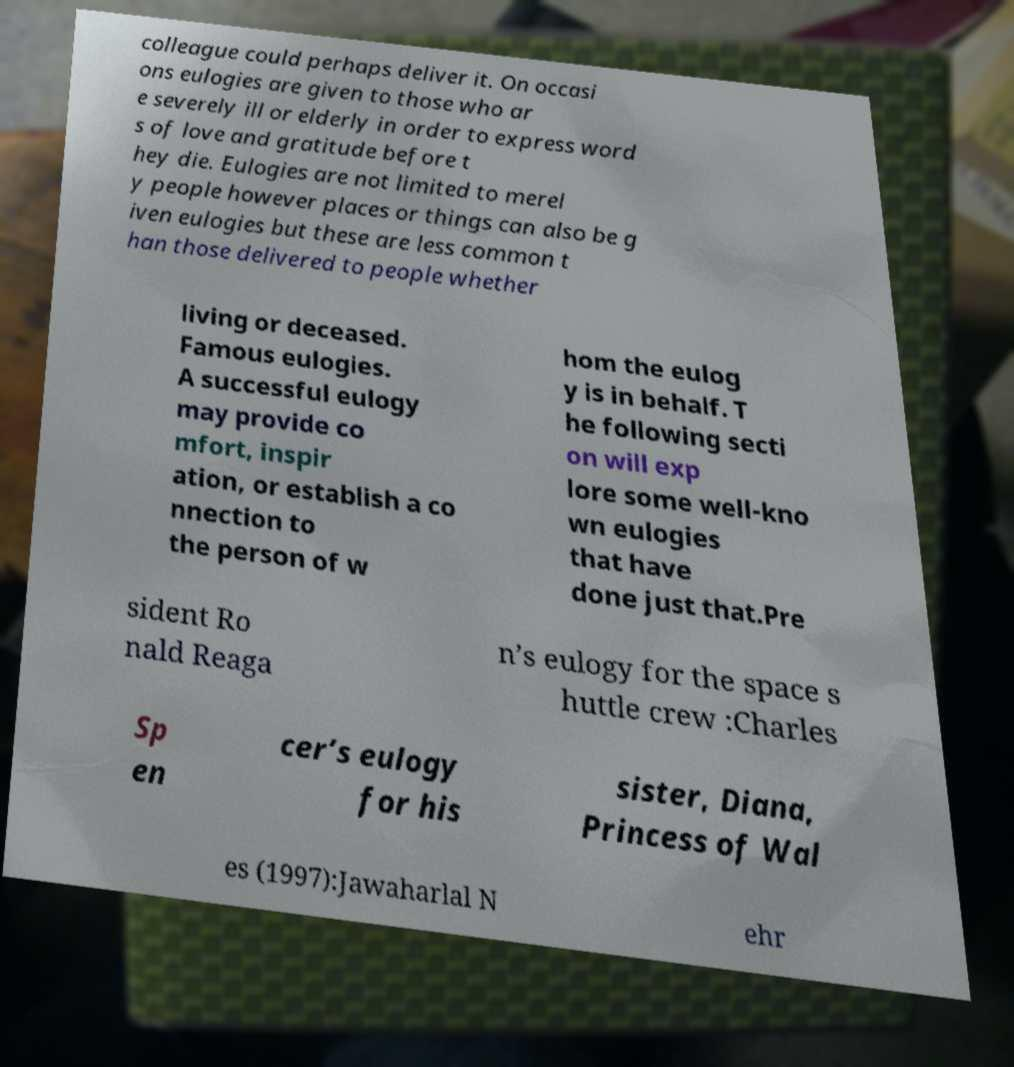What messages or text are displayed in this image? I need them in a readable, typed format. colleague could perhaps deliver it. On occasi ons eulogies are given to those who ar e severely ill or elderly in order to express word s of love and gratitude before t hey die. Eulogies are not limited to merel y people however places or things can also be g iven eulogies but these are less common t han those delivered to people whether living or deceased. Famous eulogies. A successful eulogy may provide co mfort, inspir ation, or establish a co nnection to the person of w hom the eulog y is in behalf. T he following secti on will exp lore some well-kno wn eulogies that have done just that.Pre sident Ro nald Reaga n’s eulogy for the space s huttle crew :Charles Sp en cer’s eulogy for his sister, Diana, Princess of Wal es (1997):Jawaharlal N ehr 